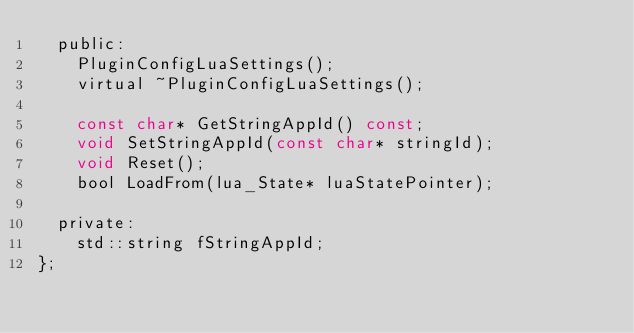Convert code to text. <code><loc_0><loc_0><loc_500><loc_500><_C_>	public:
		PluginConfigLuaSettings();
		virtual ~PluginConfigLuaSettings();

		const char* GetStringAppId() const;
		void SetStringAppId(const char* stringId);
		void Reset();
		bool LoadFrom(lua_State* luaStatePointer);

	private:
		std::string fStringAppId;
};
</code> 